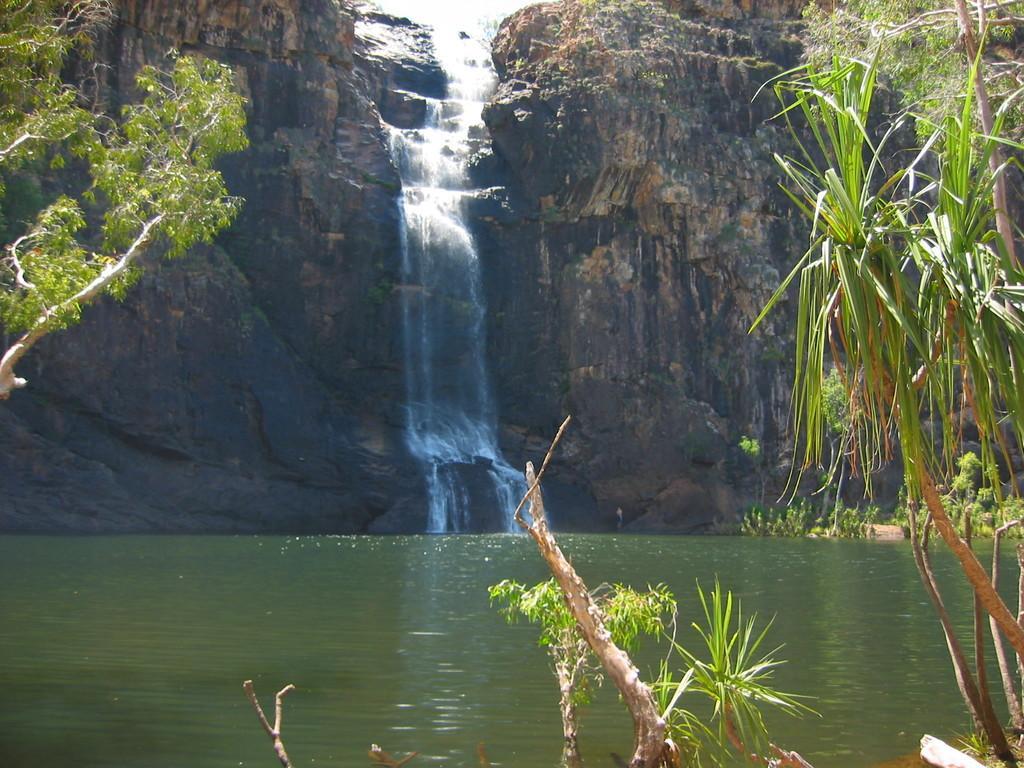In one or two sentences, can you explain what this image depicts? In this picture we can see leaves, branches and water. In the background of the image we can see rock and waterfall. 